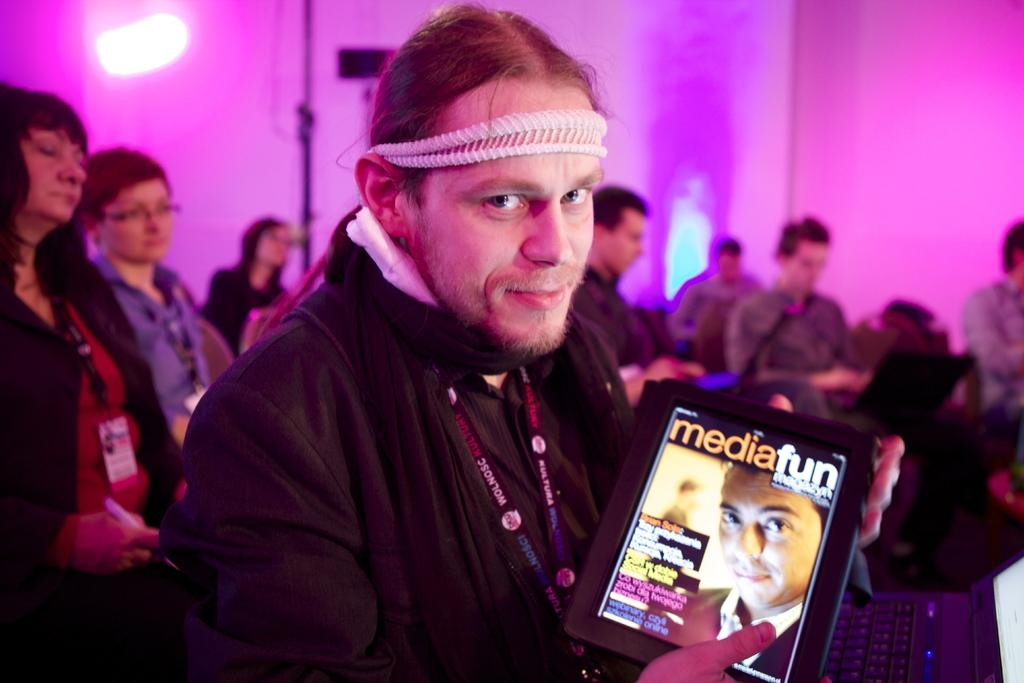What is the person in the image holding? The person in the image is holding a tab. What can be seen in the room in the image? There are people sitting in the room in the image. What is happening on the walls in the image? There are lights flashing on the walls in the image. What type of cloud can be seen in the image? There is no cloud present in the image. What kind of music is being played in the image? There is no music being played in the image. 